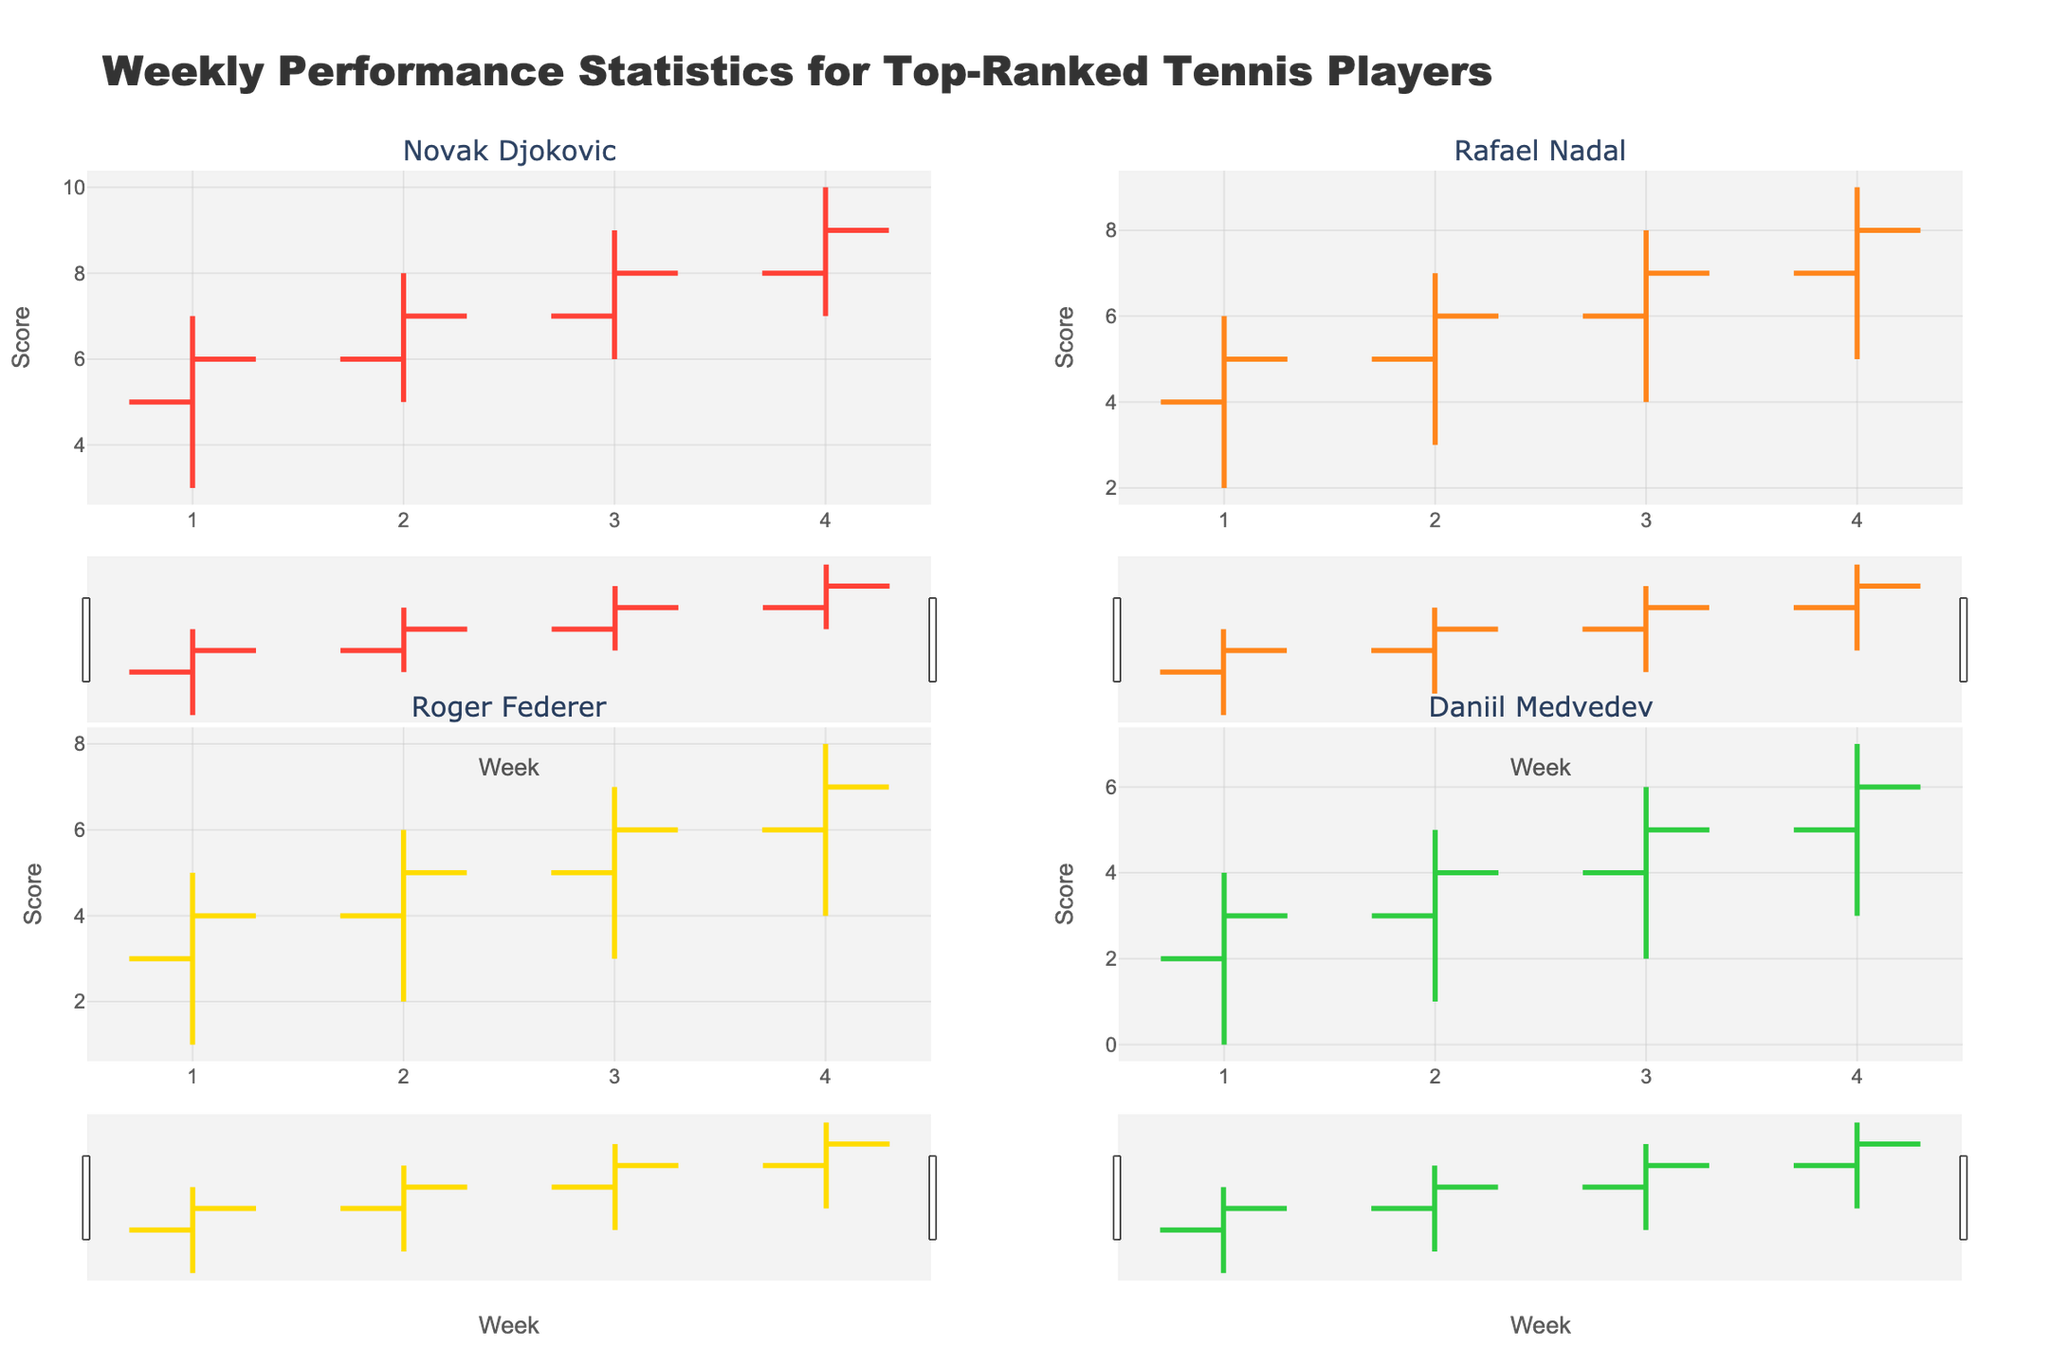What's the title of the figure? The title of the figure is displayed at the top of the figure, providing a summary of what the chart represents.
Answer: Weekly Performance Statistics for Top-Ranked Tennis Players What's the score range for Rafael Nadal in Week 3? From Rafael Nadal's OHLC chart in Week 3, the `Low` is 4 and the `High` is 8.
Answer: 4 to 8 Who had the highest `High` score in Week 4? By comparing the `High` values in Week 4 across all players, Novak Djokovic's `High` is 10, which is the highest.
Answer: Novak Djokovic Which player showed the most consistent performance across the 4 weeks based on their `Open` and `Close` scores? Consistency can be assessed by minimal variance between `Open` and `Close` scores. Roger Federer's scores gradually increase from 3 to 7 with consistent differences each week.
Answer: Roger Federer In which week did Daniil Medvedev have his lowest `Low` score? By examining Daniil Medvedev's `Low` scores, the lowest occurs in Week 1, which is 0.
Answer: Week 1 How did Novak Djokovic's `Close` score in Week 2 compare to his `Close` score in Week 1? Novak Djokovic's `Close` score increased from 6 in Week 1 to 7 in Week 2.
Answer: Increased What's the average of the `Close` scores for Rafael Nadal over the 4 weeks? Adding Rafael Nadal's `Close` scores (5, 6, 7, 8) and dividing by 4 gives the average: (5 + 6 + 7 + 8) / 4 = 6.5
Answer: 6.5 How much did Roger Federer's `Open` score increase from Week 1 to Week 4? Roger Federer's `Open` scores increased from 3 in Week 1 to 6 in Week 4, so the increase is 6 - 3 = 3.
Answer: 3 Who had a higher `High` score in Week 2, Rafael Nadal or Daniil Medvedev? Comparing the `High` scores for Week 2, Rafael Nadal had 7, while Daniil Medvedev had 5. Thus, Rafael Nadal had the higher `High` score.
Answer: Rafael Nadal Which player's `Close` score remained the same for two consecutive weeks? By checking the `Close` scores for consistency week-to-week, Daniil Medvedev's `Close` score is 6 in both Weeks 3 and 4.
Answer: Daniil Medvedev 